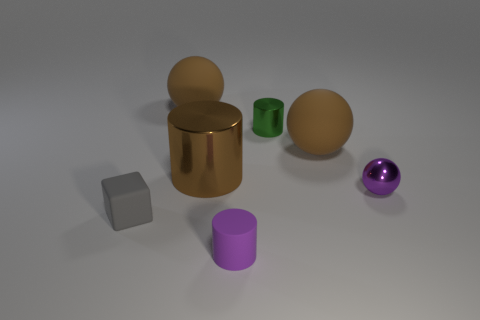Add 3 large balls. How many objects exist? 10 Subtract all spheres. How many objects are left? 4 Add 2 large metallic cylinders. How many large metallic cylinders are left? 3 Add 6 small blue rubber blocks. How many small blue rubber blocks exist? 6 Subtract 0 blue cubes. How many objects are left? 7 Subtract all red cylinders. Subtract all tiny purple things. How many objects are left? 5 